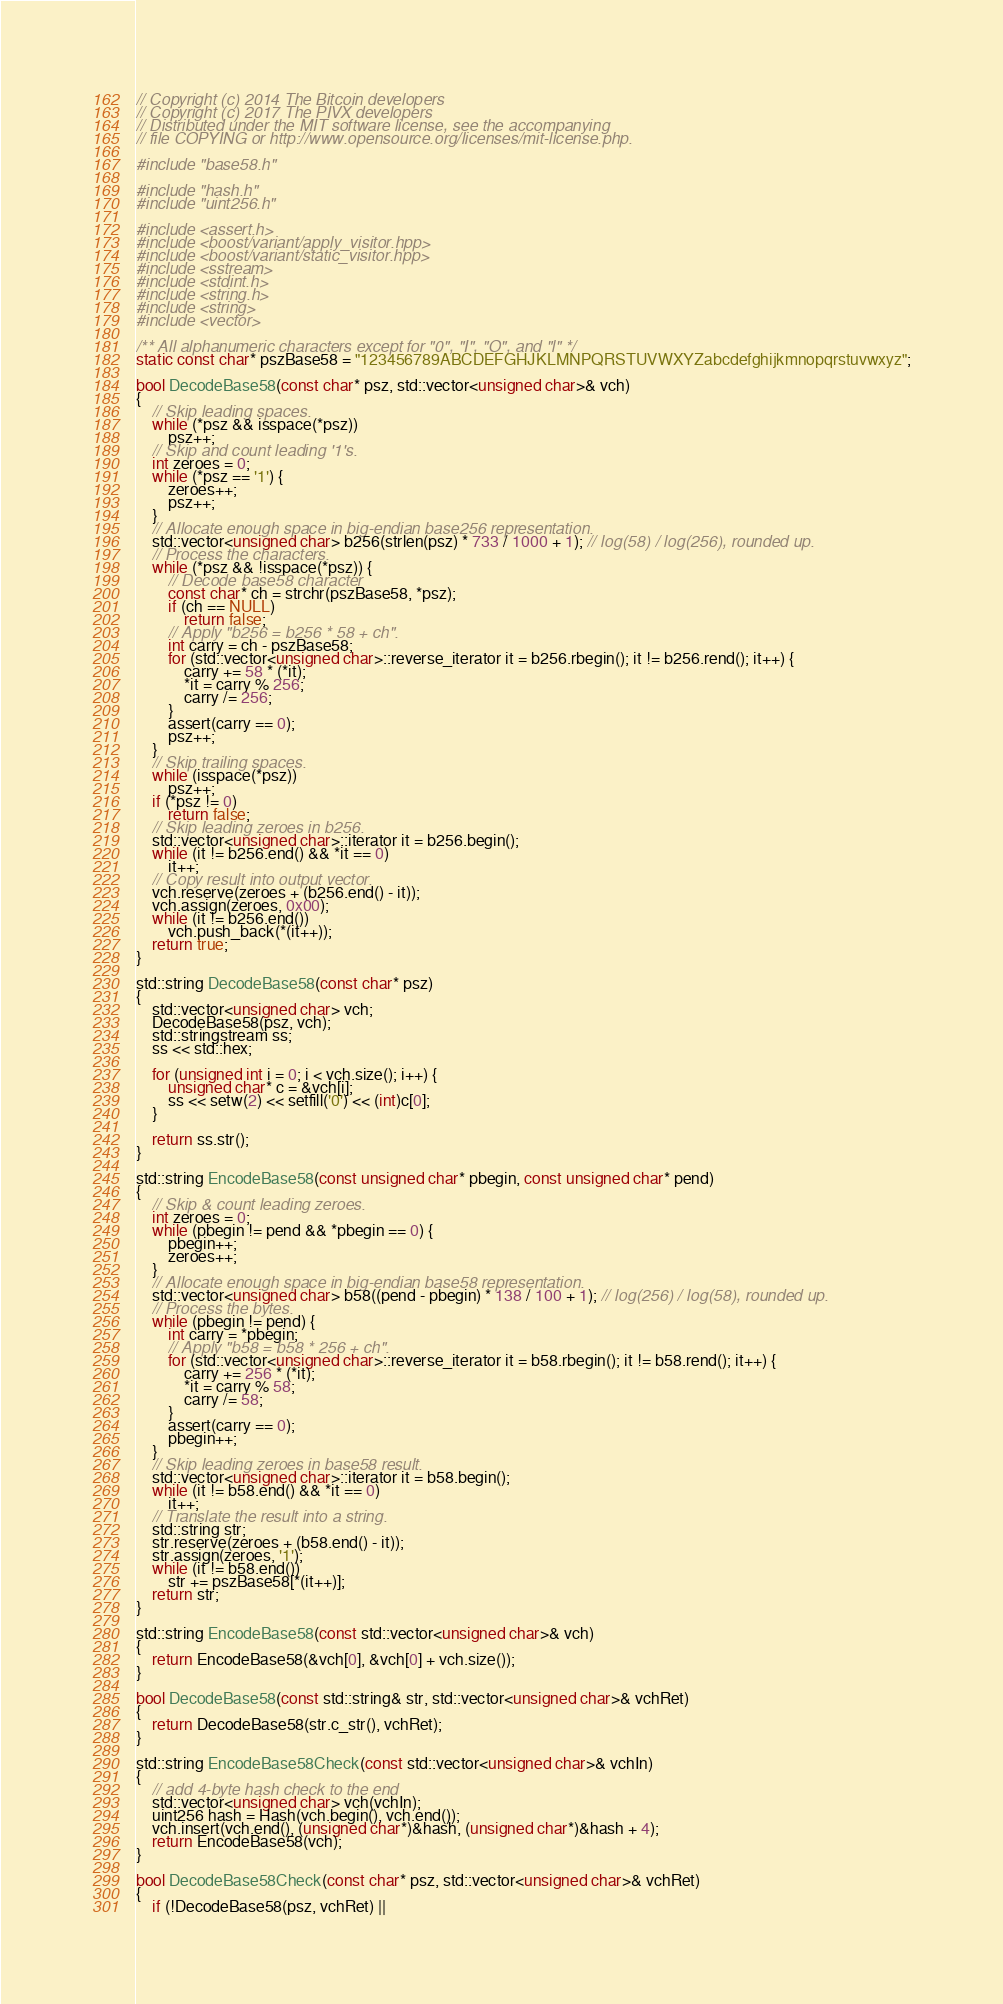Convert code to text. <code><loc_0><loc_0><loc_500><loc_500><_C++_>// Copyright (c) 2014 The Bitcoin developers
// Copyright (c) 2017 The PIVX developers
// Distributed under the MIT software license, see the accompanying
// file COPYING or http://www.opensource.org/licenses/mit-license.php.

#include "base58.h"

#include "hash.h"
#include "uint256.h"

#include <assert.h>
#include <boost/variant/apply_visitor.hpp>
#include <boost/variant/static_visitor.hpp>
#include <sstream>
#include <stdint.h>
#include <string.h>
#include <string>
#include <vector>

/** All alphanumeric characters except for "0", "I", "O", and "l" */
static const char* pszBase58 = "123456789ABCDEFGHJKLMNPQRSTUVWXYZabcdefghijkmnopqrstuvwxyz";

bool DecodeBase58(const char* psz, std::vector<unsigned char>& vch)
{
    // Skip leading spaces.
    while (*psz && isspace(*psz))
        psz++;
    // Skip and count leading '1's.
    int zeroes = 0;
    while (*psz == '1') {
        zeroes++;
        psz++;
    }
    // Allocate enough space in big-endian base256 representation.
    std::vector<unsigned char> b256(strlen(psz) * 733 / 1000 + 1); // log(58) / log(256), rounded up.
    // Process the characters.
    while (*psz && !isspace(*psz)) {
        // Decode base58 character
        const char* ch = strchr(pszBase58, *psz);
        if (ch == NULL)
            return false;
        // Apply "b256 = b256 * 58 + ch".
        int carry = ch - pszBase58;
        for (std::vector<unsigned char>::reverse_iterator it = b256.rbegin(); it != b256.rend(); it++) {
            carry += 58 * (*it);
            *it = carry % 256;
            carry /= 256;
        }
        assert(carry == 0);
        psz++;
    }
    // Skip trailing spaces.
    while (isspace(*psz))
        psz++;
    if (*psz != 0)
        return false;
    // Skip leading zeroes in b256.
    std::vector<unsigned char>::iterator it = b256.begin();
    while (it != b256.end() && *it == 0)
        it++;
    // Copy result into output vector.
    vch.reserve(zeroes + (b256.end() - it));
    vch.assign(zeroes, 0x00);
    while (it != b256.end())
        vch.push_back(*(it++));
    return true;
}

std::string DecodeBase58(const char* psz)
{
    std::vector<unsigned char> vch;
    DecodeBase58(psz, vch);
    std::stringstream ss;
    ss << std::hex;

    for (unsigned int i = 0; i < vch.size(); i++) {
        unsigned char* c = &vch[i];
        ss << setw(2) << setfill('0') << (int)c[0];
    }

    return ss.str();
}

std::string EncodeBase58(const unsigned char* pbegin, const unsigned char* pend)
{
    // Skip & count leading zeroes.
    int zeroes = 0;
    while (pbegin != pend && *pbegin == 0) {
        pbegin++;
        zeroes++;
    }
    // Allocate enough space in big-endian base58 representation.
    std::vector<unsigned char> b58((pend - pbegin) * 138 / 100 + 1); // log(256) / log(58), rounded up.
    // Process the bytes.
    while (pbegin != pend) {
        int carry = *pbegin;
        // Apply "b58 = b58 * 256 + ch".
        for (std::vector<unsigned char>::reverse_iterator it = b58.rbegin(); it != b58.rend(); it++) {
            carry += 256 * (*it);
            *it = carry % 58;
            carry /= 58;
        }
        assert(carry == 0);
        pbegin++;
    }
    // Skip leading zeroes in base58 result.
    std::vector<unsigned char>::iterator it = b58.begin();
    while (it != b58.end() && *it == 0)
        it++;
    // Translate the result into a string.
    std::string str;
    str.reserve(zeroes + (b58.end() - it));
    str.assign(zeroes, '1');
    while (it != b58.end())
        str += pszBase58[*(it++)];
    return str;
}

std::string EncodeBase58(const std::vector<unsigned char>& vch)
{
    return EncodeBase58(&vch[0], &vch[0] + vch.size());
}

bool DecodeBase58(const std::string& str, std::vector<unsigned char>& vchRet)
{
    return DecodeBase58(str.c_str(), vchRet);
}

std::string EncodeBase58Check(const std::vector<unsigned char>& vchIn)
{
    // add 4-byte hash check to the end
    std::vector<unsigned char> vch(vchIn);
    uint256 hash = Hash(vch.begin(), vch.end());
    vch.insert(vch.end(), (unsigned char*)&hash, (unsigned char*)&hash + 4);
    return EncodeBase58(vch);
}

bool DecodeBase58Check(const char* psz, std::vector<unsigned char>& vchRet)
{
    if (!DecodeBase58(psz, vchRet) ||</code> 